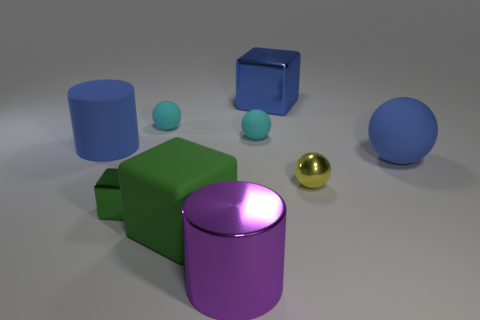Is the number of metallic cubes left of the big matte cylinder the same as the number of big blocks that are in front of the yellow shiny object?
Give a very brief answer. No. How big is the shiny cube in front of the blue shiny cube?
Your response must be concise. Small. Are there any blue balls made of the same material as the large green block?
Your answer should be very brief. Yes. There is a big thing right of the yellow sphere; is it the same color as the rubber block?
Your answer should be very brief. No. Are there the same number of tiny cyan matte spheres to the left of the metallic cylinder and big green shiny cubes?
Your response must be concise. No. Is there a metallic object that has the same color as the big matte cube?
Provide a short and direct response. Yes. Do the blue matte sphere and the shiny sphere have the same size?
Make the answer very short. No. What is the size of the blue rubber thing that is left of the large block that is to the left of the purple shiny cylinder?
Make the answer very short. Large. There is a matte thing that is both on the left side of the large blue metal object and on the right side of the green rubber object; what size is it?
Your answer should be very brief. Small. What number of green matte cylinders are the same size as the blue block?
Your answer should be compact. 0. 